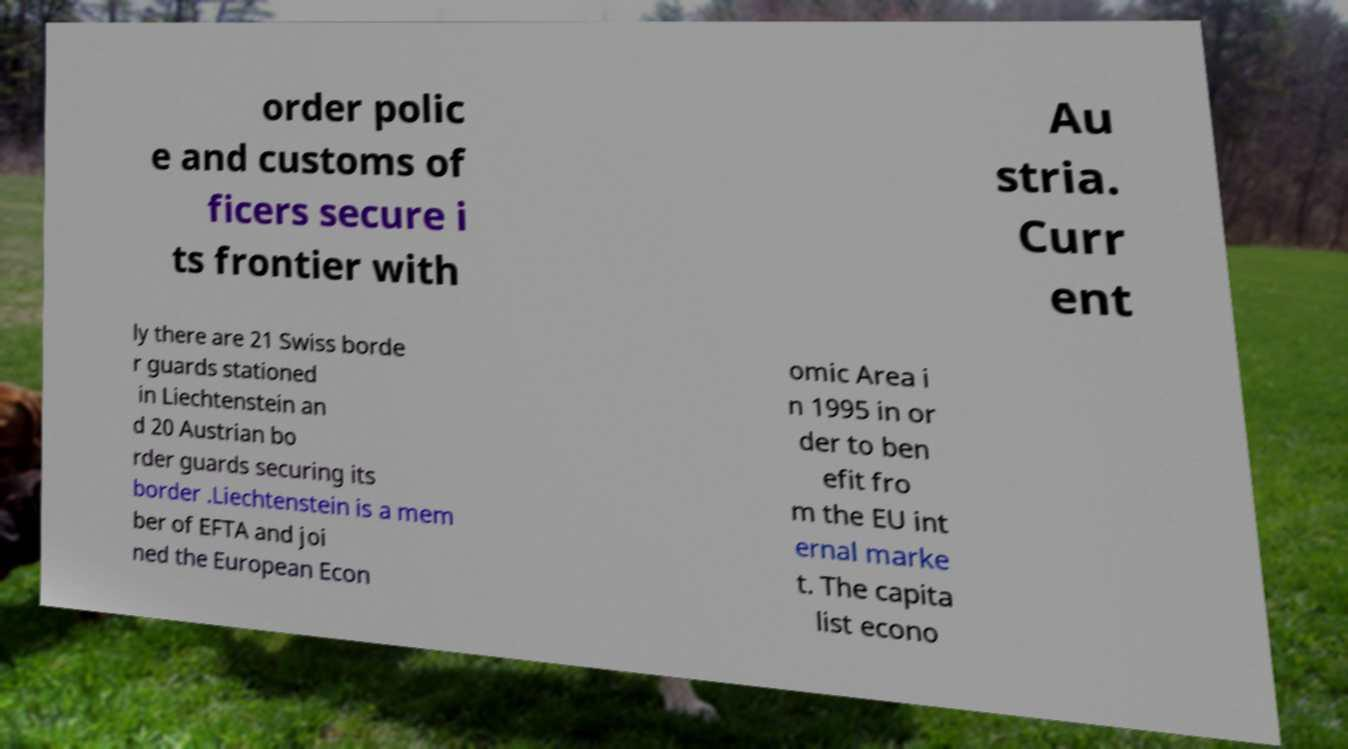Can you read and provide the text displayed in the image?This photo seems to have some interesting text. Can you extract and type it out for me? order polic e and customs of ficers secure i ts frontier with Au stria. Curr ent ly there are 21 Swiss borde r guards stationed in Liechtenstein an d 20 Austrian bo rder guards securing its border .Liechtenstein is a mem ber of EFTA and joi ned the European Econ omic Area i n 1995 in or der to ben efit fro m the EU int ernal marke t. The capita list econo 